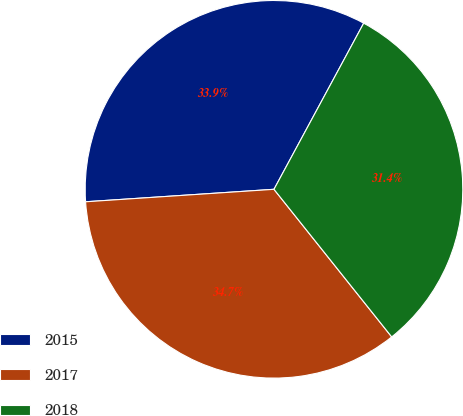<chart> <loc_0><loc_0><loc_500><loc_500><pie_chart><fcel>2015<fcel>2017<fcel>2018<nl><fcel>33.93%<fcel>34.66%<fcel>31.4%<nl></chart> 